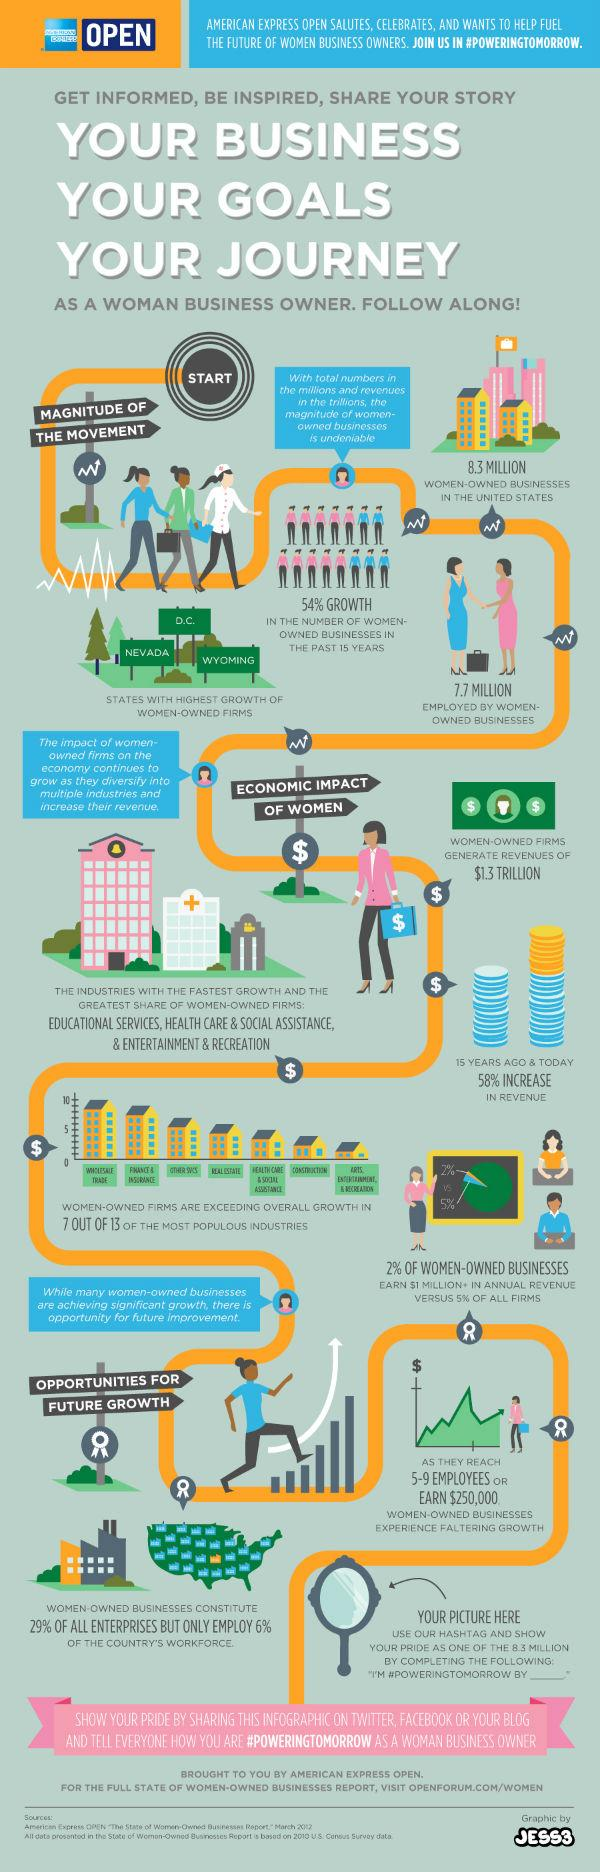Mention a couple of crucial points in this snapshot. According to data, there are approximately 7.7 million employed individuals in women-owned businesses in the United States. According to recent statistics, there are approximately 8.3 million women-owned businesses in the United States. 